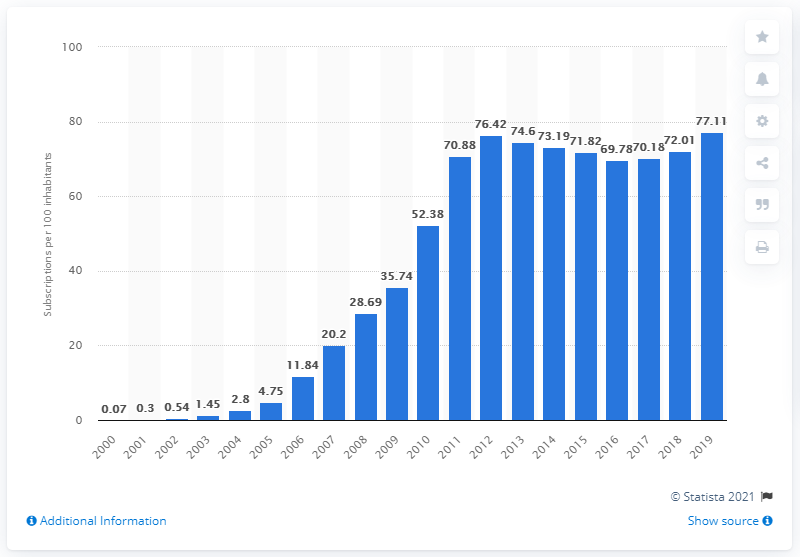Indicate a few pertinent items in this graphic. By 2000, the number of mobile subscriptions per 100 inhabitants in Sudan was. During the period between 2000 and 2019, there were an average of 77.11 mobile subscriptions registered for every 100 people in Sudan. 